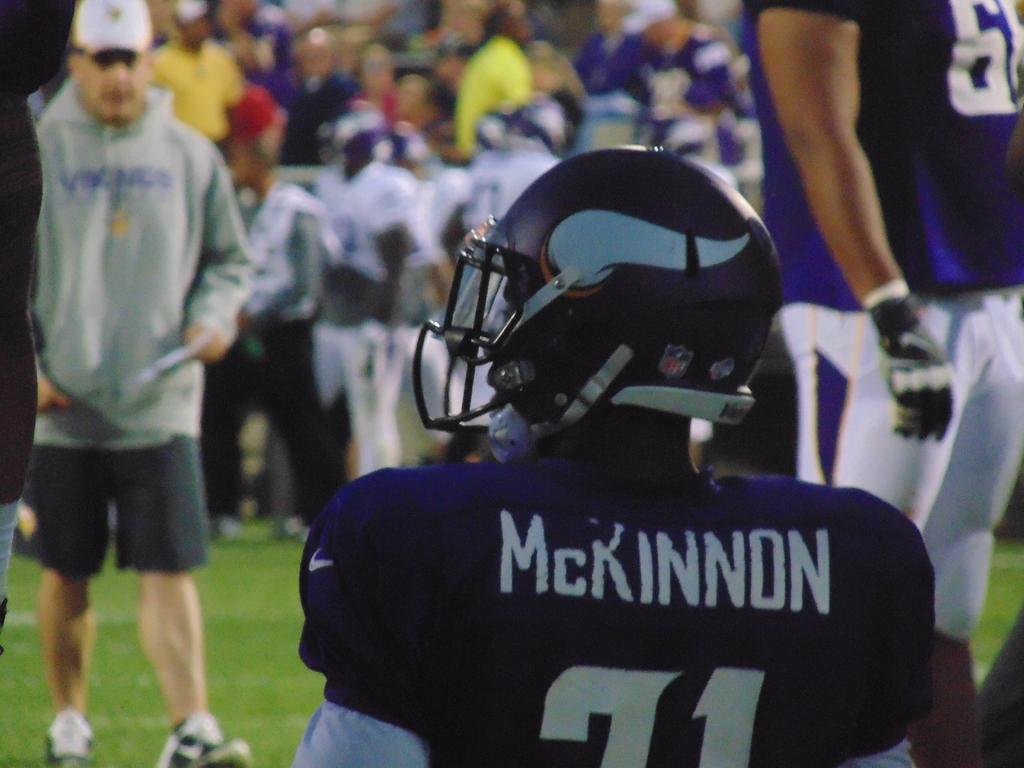How would you summarize this image in a sentence or two? In this image we can see a person sitting and wearing a helmet. And we can see the grass. And we can see the surrounding people. 